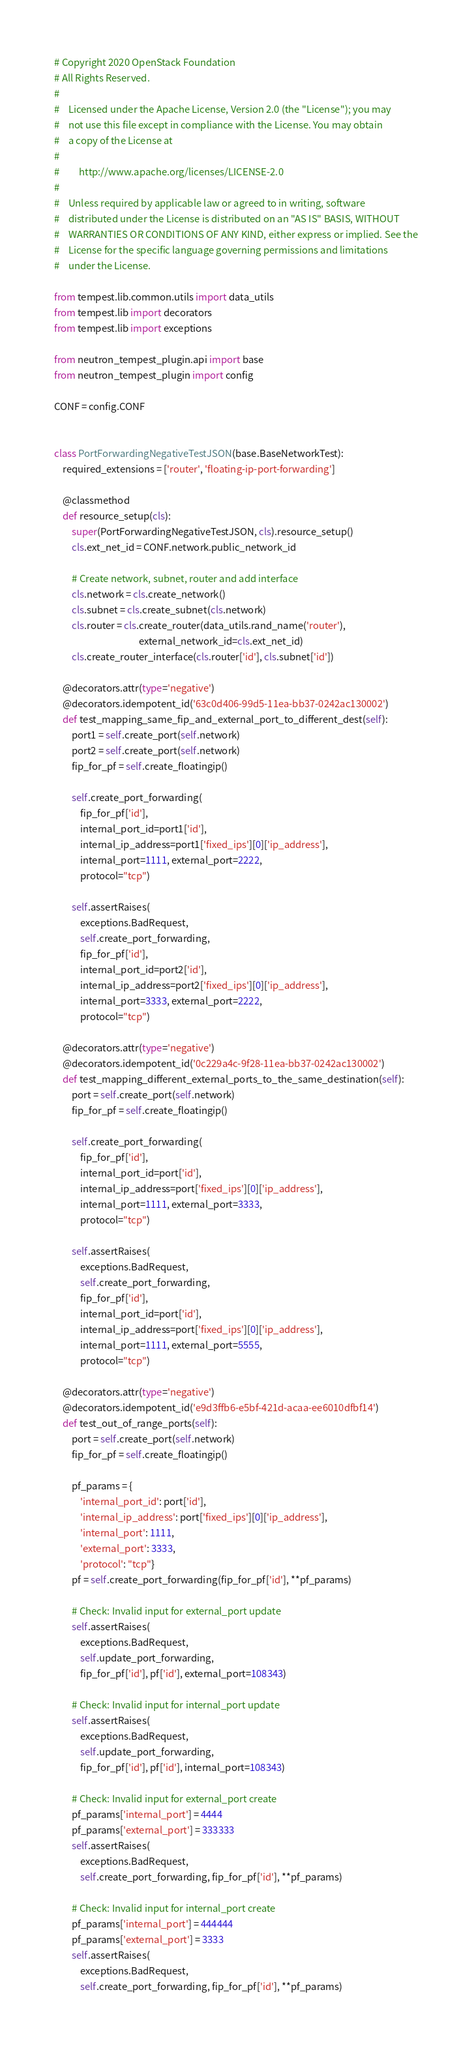<code> <loc_0><loc_0><loc_500><loc_500><_Python_># Copyright 2020 OpenStack Foundation
# All Rights Reserved.
#
#    Licensed under the Apache License, Version 2.0 (the "License"); you may
#    not use this file except in compliance with the License. You may obtain
#    a copy of the License at
#
#         http://www.apache.org/licenses/LICENSE-2.0
#
#    Unless required by applicable law or agreed to in writing, software
#    distributed under the License is distributed on an "AS IS" BASIS, WITHOUT
#    WARRANTIES OR CONDITIONS OF ANY KIND, either express or implied. See the
#    License for the specific language governing permissions and limitations
#    under the License.

from tempest.lib.common.utils import data_utils
from tempest.lib import decorators
from tempest.lib import exceptions

from neutron_tempest_plugin.api import base
from neutron_tempest_plugin import config

CONF = config.CONF


class PortForwardingNegativeTestJSON(base.BaseNetworkTest):
    required_extensions = ['router', 'floating-ip-port-forwarding']

    @classmethod
    def resource_setup(cls):
        super(PortForwardingNegativeTestJSON, cls).resource_setup()
        cls.ext_net_id = CONF.network.public_network_id

        # Create network, subnet, router and add interface
        cls.network = cls.create_network()
        cls.subnet = cls.create_subnet(cls.network)
        cls.router = cls.create_router(data_utils.rand_name('router'),
                                       external_network_id=cls.ext_net_id)
        cls.create_router_interface(cls.router['id'], cls.subnet['id'])

    @decorators.attr(type='negative')
    @decorators.idempotent_id('63c0d406-99d5-11ea-bb37-0242ac130002')
    def test_mapping_same_fip_and_external_port_to_different_dest(self):
        port1 = self.create_port(self.network)
        port2 = self.create_port(self.network)
        fip_for_pf = self.create_floatingip()

        self.create_port_forwarding(
            fip_for_pf['id'],
            internal_port_id=port1['id'],
            internal_ip_address=port1['fixed_ips'][0]['ip_address'],
            internal_port=1111, external_port=2222,
            protocol="tcp")

        self.assertRaises(
            exceptions.BadRequest,
            self.create_port_forwarding,
            fip_for_pf['id'],
            internal_port_id=port2['id'],
            internal_ip_address=port2['fixed_ips'][0]['ip_address'],
            internal_port=3333, external_port=2222,
            protocol="tcp")

    @decorators.attr(type='negative')
    @decorators.idempotent_id('0c229a4c-9f28-11ea-bb37-0242ac130002')
    def test_mapping_different_external_ports_to_the_same_destination(self):
        port = self.create_port(self.network)
        fip_for_pf = self.create_floatingip()

        self.create_port_forwarding(
            fip_for_pf['id'],
            internal_port_id=port['id'],
            internal_ip_address=port['fixed_ips'][0]['ip_address'],
            internal_port=1111, external_port=3333,
            protocol="tcp")

        self.assertRaises(
            exceptions.BadRequest,
            self.create_port_forwarding,
            fip_for_pf['id'],
            internal_port_id=port['id'],
            internal_ip_address=port['fixed_ips'][0]['ip_address'],
            internal_port=1111, external_port=5555,
            protocol="tcp")

    @decorators.attr(type='negative')
    @decorators.idempotent_id('e9d3ffb6-e5bf-421d-acaa-ee6010dfbf14')
    def test_out_of_range_ports(self):
        port = self.create_port(self.network)
        fip_for_pf = self.create_floatingip()

        pf_params = {
            'internal_port_id': port['id'],
            'internal_ip_address': port['fixed_ips'][0]['ip_address'],
            'internal_port': 1111,
            'external_port': 3333,
            'protocol': "tcp"}
        pf = self.create_port_forwarding(fip_for_pf['id'], **pf_params)

        # Check: Invalid input for external_port update
        self.assertRaises(
            exceptions.BadRequest,
            self.update_port_forwarding,
            fip_for_pf['id'], pf['id'], external_port=108343)

        # Check: Invalid input for internal_port update
        self.assertRaises(
            exceptions.BadRequest,
            self.update_port_forwarding,
            fip_for_pf['id'], pf['id'], internal_port=108343)

        # Check: Invalid input for external_port create
        pf_params['internal_port'] = 4444
        pf_params['external_port'] = 333333
        self.assertRaises(
            exceptions.BadRequest,
            self.create_port_forwarding, fip_for_pf['id'], **pf_params)

        # Check: Invalid input for internal_port create
        pf_params['internal_port'] = 444444
        pf_params['external_port'] = 3333
        self.assertRaises(
            exceptions.BadRequest,
            self.create_port_forwarding, fip_for_pf['id'], **pf_params)
</code> 